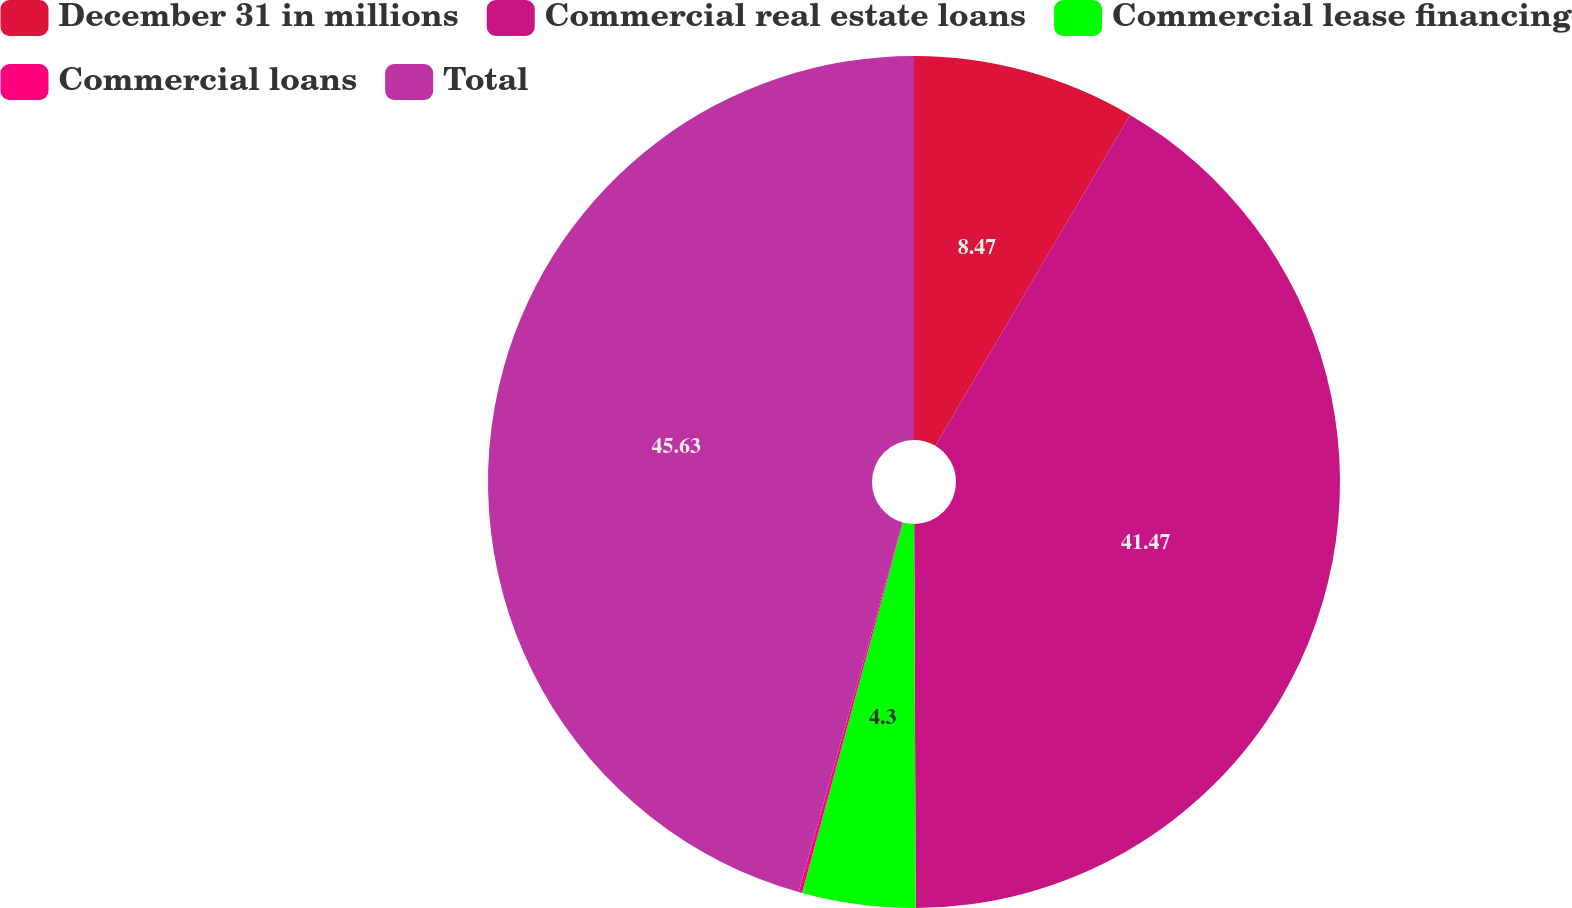Convert chart. <chart><loc_0><loc_0><loc_500><loc_500><pie_chart><fcel>December 31 in millions<fcel>Commercial real estate loans<fcel>Commercial lease financing<fcel>Commercial loans<fcel>Total<nl><fcel>8.47%<fcel>41.47%<fcel>4.3%<fcel>0.13%<fcel>45.64%<nl></chart> 